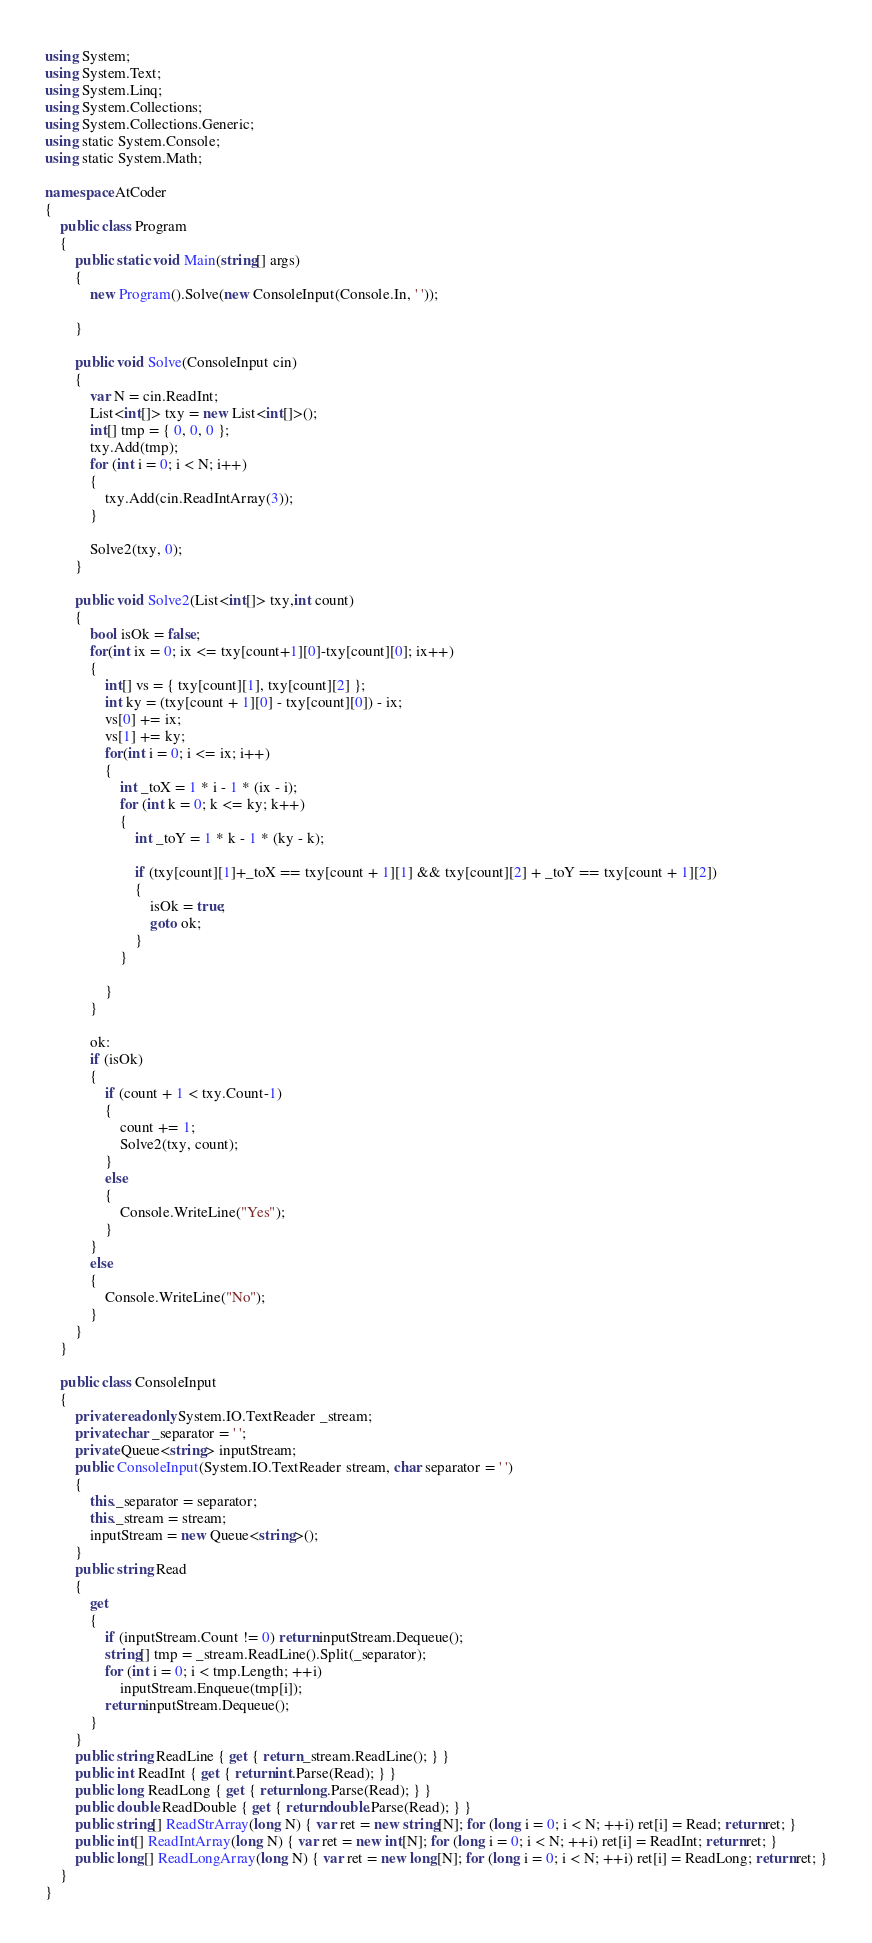Convert code to text. <code><loc_0><loc_0><loc_500><loc_500><_C#_>using System;
using System.Text;
using System.Linq;
using System.Collections;
using System.Collections.Generic;
using static System.Console;
using static System.Math;

namespace AtCoder
{
    public class Program
    {
        public static void Main(string[] args)
        {
            new Program().Solve(new ConsoleInput(Console.In, ' '));

        }

        public void Solve(ConsoleInput cin)
        {
            var N = cin.ReadInt;
            List<int[]> txy = new List<int[]>();
            int[] tmp = { 0, 0, 0 };
            txy.Add(tmp);
            for (int i = 0; i < N; i++)
            {
                txy.Add(cin.ReadIntArray(3));
            }

            Solve2(txy, 0);
        }

        public void Solve2(List<int[]> txy,int count)
        {
            bool isOk = false;
            for(int ix = 0; ix <= txy[count+1][0]-txy[count][0]; ix++)
            {
                int[] vs = { txy[count][1], txy[count][2] };
                int ky = (txy[count + 1][0] - txy[count][0]) - ix;
                vs[0] += ix;
                vs[1] += ky;
                for(int i = 0; i <= ix; i++)
                {
                    int _toX = 1 * i - 1 * (ix - i);
                    for (int k = 0; k <= ky; k++)
                    {
                        int _toY = 1 * k - 1 * (ky - k);

                        if (txy[count][1]+_toX == txy[count + 1][1] && txy[count][2] + _toY == txy[count + 1][2])
                        {
                            isOk = true;
                            goto ok;
                        }
                    }

                }
            }

            ok:
            if (isOk)
            {
                if (count + 1 < txy.Count-1)
                {
                    count += 1;
                    Solve2(txy, count);
                }
                else
                {
                    Console.WriteLine("Yes");
                }
            }
            else
            {
                Console.WriteLine("No");
            }
        }
    }

    public class ConsoleInput
    {
        private readonly System.IO.TextReader _stream;
        private char _separator = ' ';
        private Queue<string> inputStream;
        public ConsoleInput(System.IO.TextReader stream, char separator = ' ')
        {
            this._separator = separator;
            this._stream = stream;
            inputStream = new Queue<string>();
        }
        public string Read
        {
            get
            {
                if (inputStream.Count != 0) return inputStream.Dequeue();
                string[] tmp = _stream.ReadLine().Split(_separator);
                for (int i = 0; i < tmp.Length; ++i)
                    inputStream.Enqueue(tmp[i]);
                return inputStream.Dequeue();
            }
        }
        public string ReadLine { get { return _stream.ReadLine(); } }
        public int ReadInt { get { return int.Parse(Read); } }
        public long ReadLong { get { return long.Parse(Read); } }
        public double ReadDouble { get { return double.Parse(Read); } }
        public string[] ReadStrArray(long N) { var ret = new string[N]; for (long i = 0; i < N; ++i) ret[i] = Read; return ret; }
        public int[] ReadIntArray(long N) { var ret = new int[N]; for (long i = 0; i < N; ++i) ret[i] = ReadInt; return ret; }
        public long[] ReadLongArray(long N) { var ret = new long[N]; for (long i = 0; i < N; ++i) ret[i] = ReadLong; return ret; }
    }
}</code> 